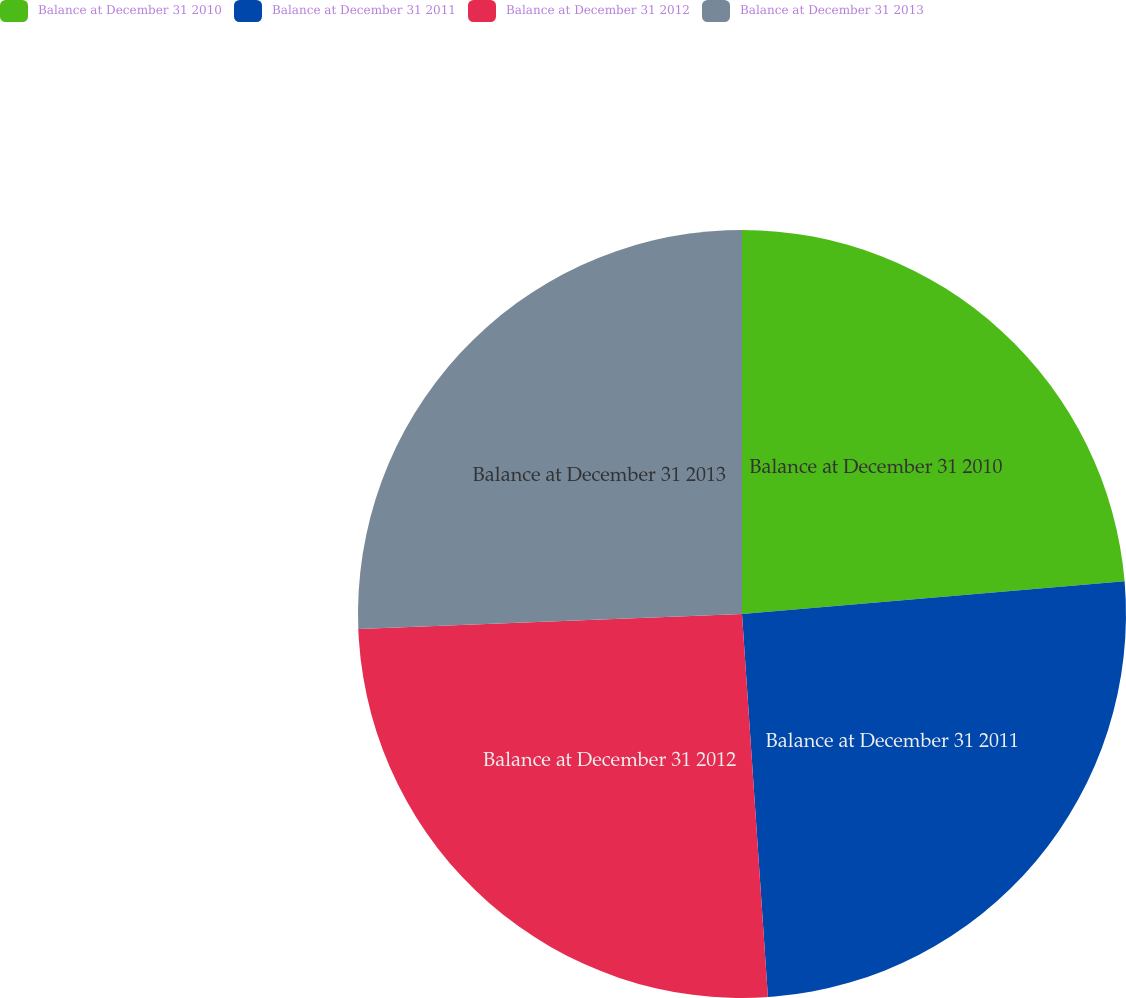Convert chart. <chart><loc_0><loc_0><loc_500><loc_500><pie_chart><fcel>Balance at December 31 2010<fcel>Balance at December 31 2011<fcel>Balance at December 31 2012<fcel>Balance at December 31 2013<nl><fcel>23.64%<fcel>25.28%<fcel>25.45%<fcel>25.62%<nl></chart> 